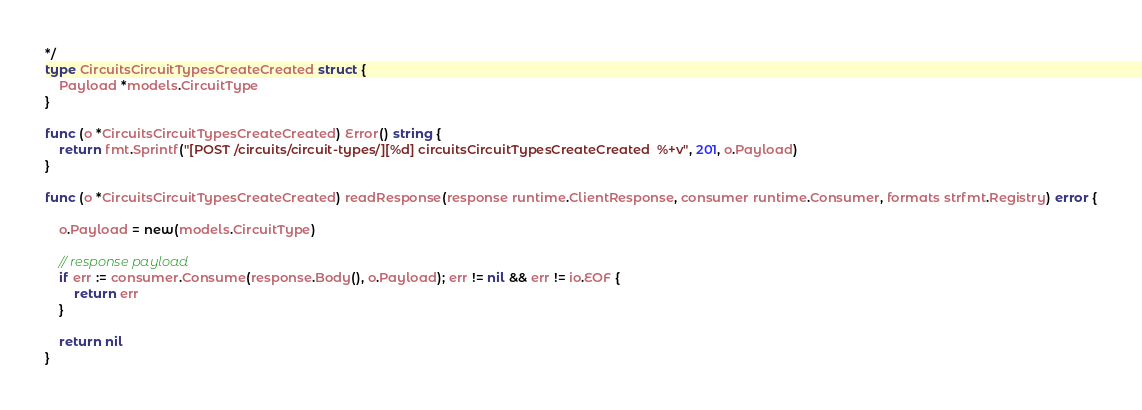Convert code to text. <code><loc_0><loc_0><loc_500><loc_500><_Go_>*/
type CircuitsCircuitTypesCreateCreated struct {
	Payload *models.CircuitType
}

func (o *CircuitsCircuitTypesCreateCreated) Error() string {
	return fmt.Sprintf("[POST /circuits/circuit-types/][%d] circuitsCircuitTypesCreateCreated  %+v", 201, o.Payload)
}

func (o *CircuitsCircuitTypesCreateCreated) readResponse(response runtime.ClientResponse, consumer runtime.Consumer, formats strfmt.Registry) error {

	o.Payload = new(models.CircuitType)

	// response payload
	if err := consumer.Consume(response.Body(), o.Payload); err != nil && err != io.EOF {
		return err
	}

	return nil
}
</code> 